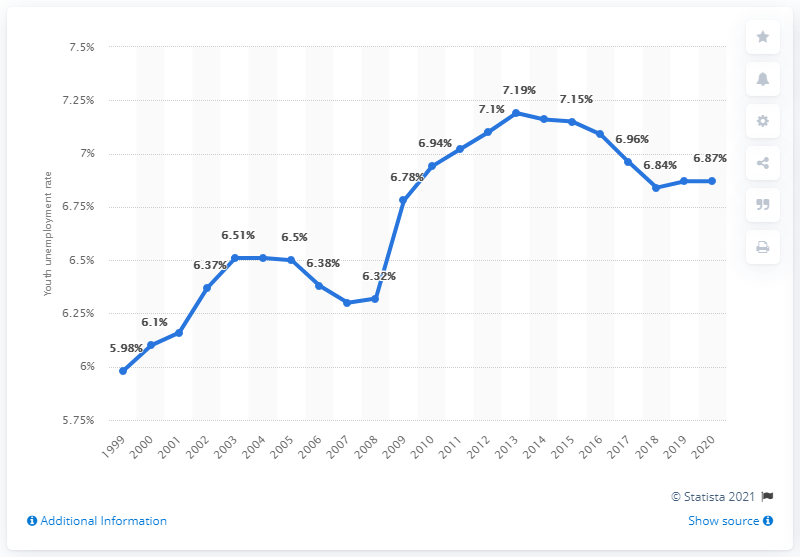List a handful of essential elements in this visual. In 2020, the youth unemployment rate in Mozambique was 6.87%. 